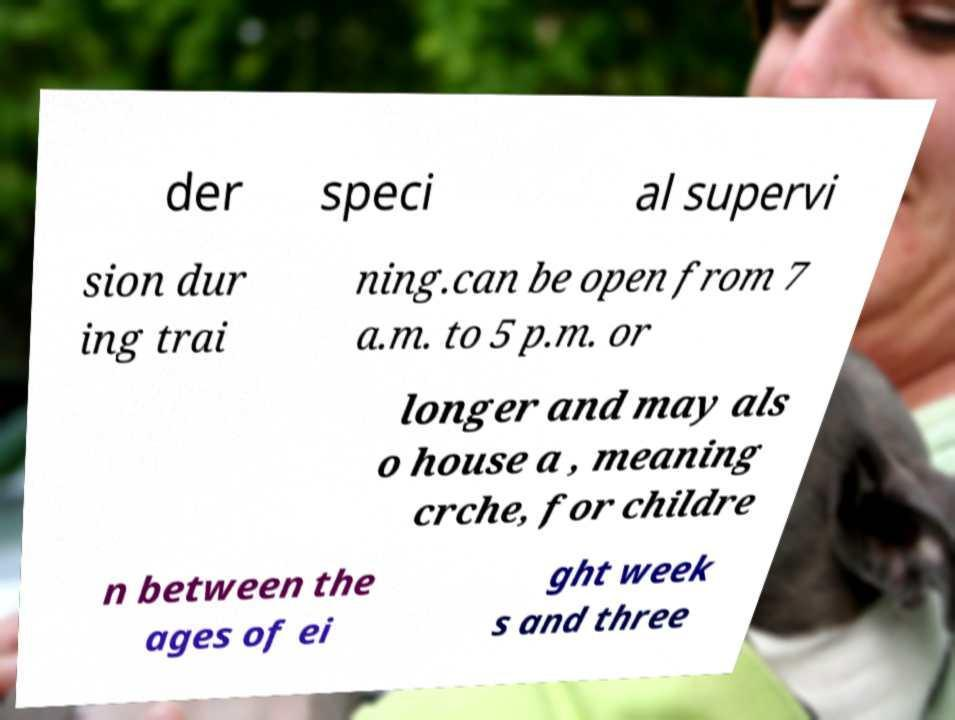Could you extract and type out the text from this image? der speci al supervi sion dur ing trai ning.can be open from 7 a.m. to 5 p.m. or longer and may als o house a , meaning crche, for childre n between the ages of ei ght week s and three 